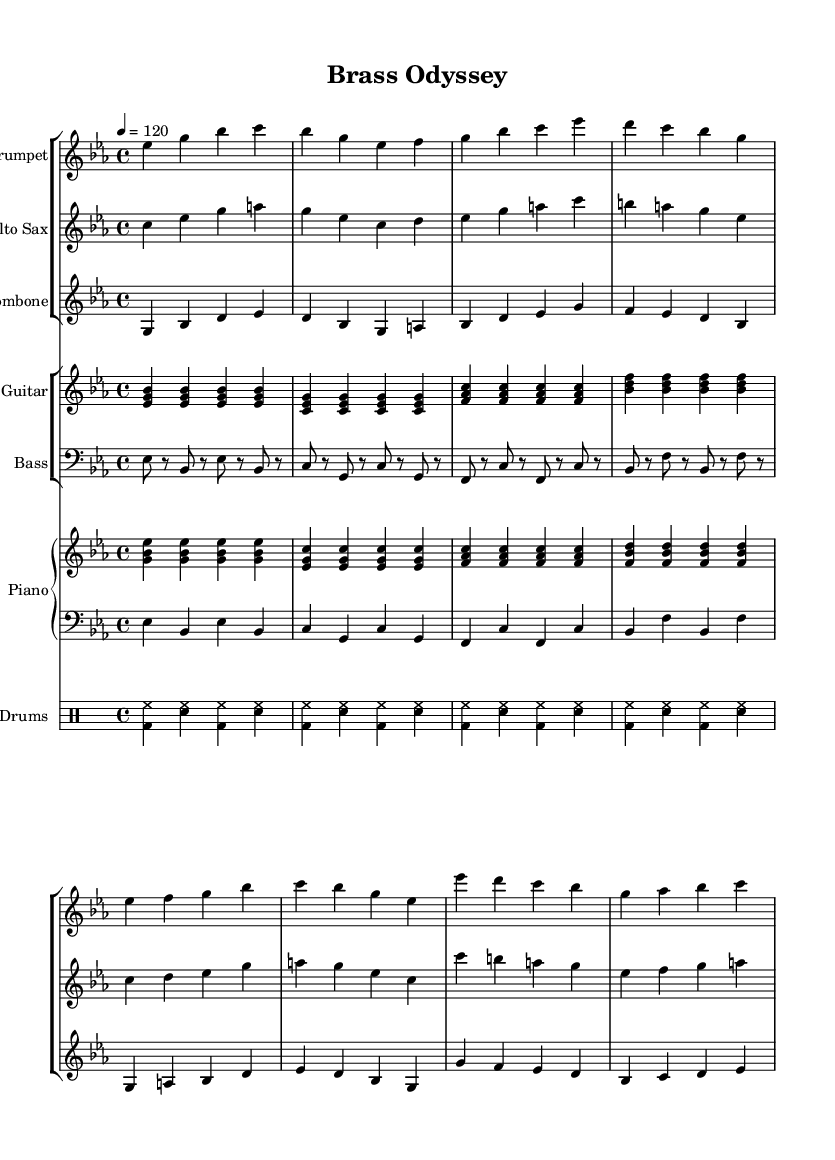What is the key signature of this music? The key signature of the music is indicated at the beginning. In this case, there are three flats (B♭, E♭, and A♭), which means the key is E♭ major.
Answer: E♭ major What is the time signature of the piece? The time signature is located at the beginning of the music, and in this case, it is 4/4, which indicates four beats per measure and a quarter note gets one beat.
Answer: 4/4 What is the tempo marking of the music? The tempo marking is shown at the beginning, which states "4 = 120," indicating that the piece should be played at a speed of 120 beats per minute, with the quarter note as the unit of measurement.
Answer: 120 How many instruments are featured in this piece? By counting the different staffs in the score, we can see that there are five distinct instruments: Trumpet, Alto Sax, Trombone, Piano (with two staves), Guitar, and Bass.
Answer: Five Which section features the prominent brass instruments? The music has sections where the trumpets, alto sax, and trombone play together prominently, especially during the intro and verse sections. These sections can be identified by their groupings in the score.
Answer: Intro and Verse What type of groove does the drum part exhibit? The drum part is described as a "basic jazz-rock groove" and is characterized by patterns of bass drum and snare in a syncopated rhythm, typical of jazz-rock styles.
Answer: Jazz-rock groove What is the structure of the harmonies used in the piano part? The piano part is structured with alternating chord voicings, primarily based on the root chords and their respective triads, providing a harmonic foundation for the piece.
Answer: Root chords and triads 